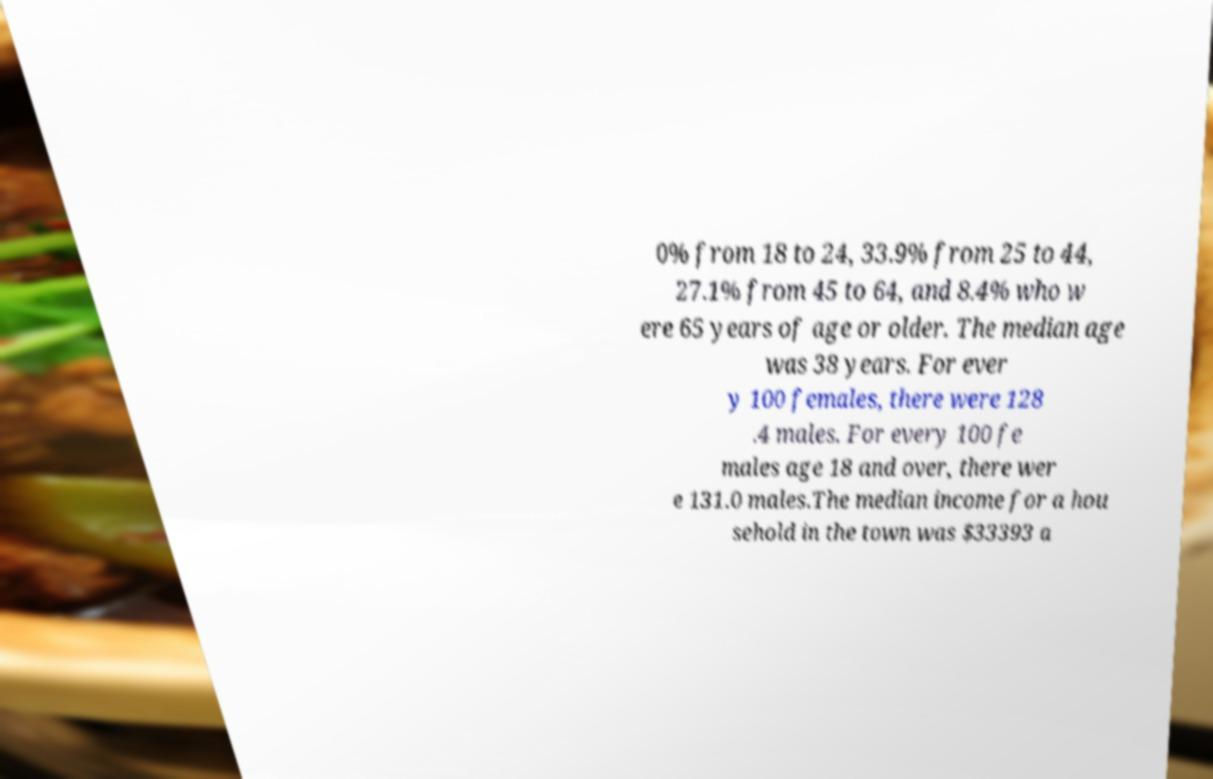Can you accurately transcribe the text from the provided image for me? 0% from 18 to 24, 33.9% from 25 to 44, 27.1% from 45 to 64, and 8.4% who w ere 65 years of age or older. The median age was 38 years. For ever y 100 females, there were 128 .4 males. For every 100 fe males age 18 and over, there wer e 131.0 males.The median income for a hou sehold in the town was $33393 a 